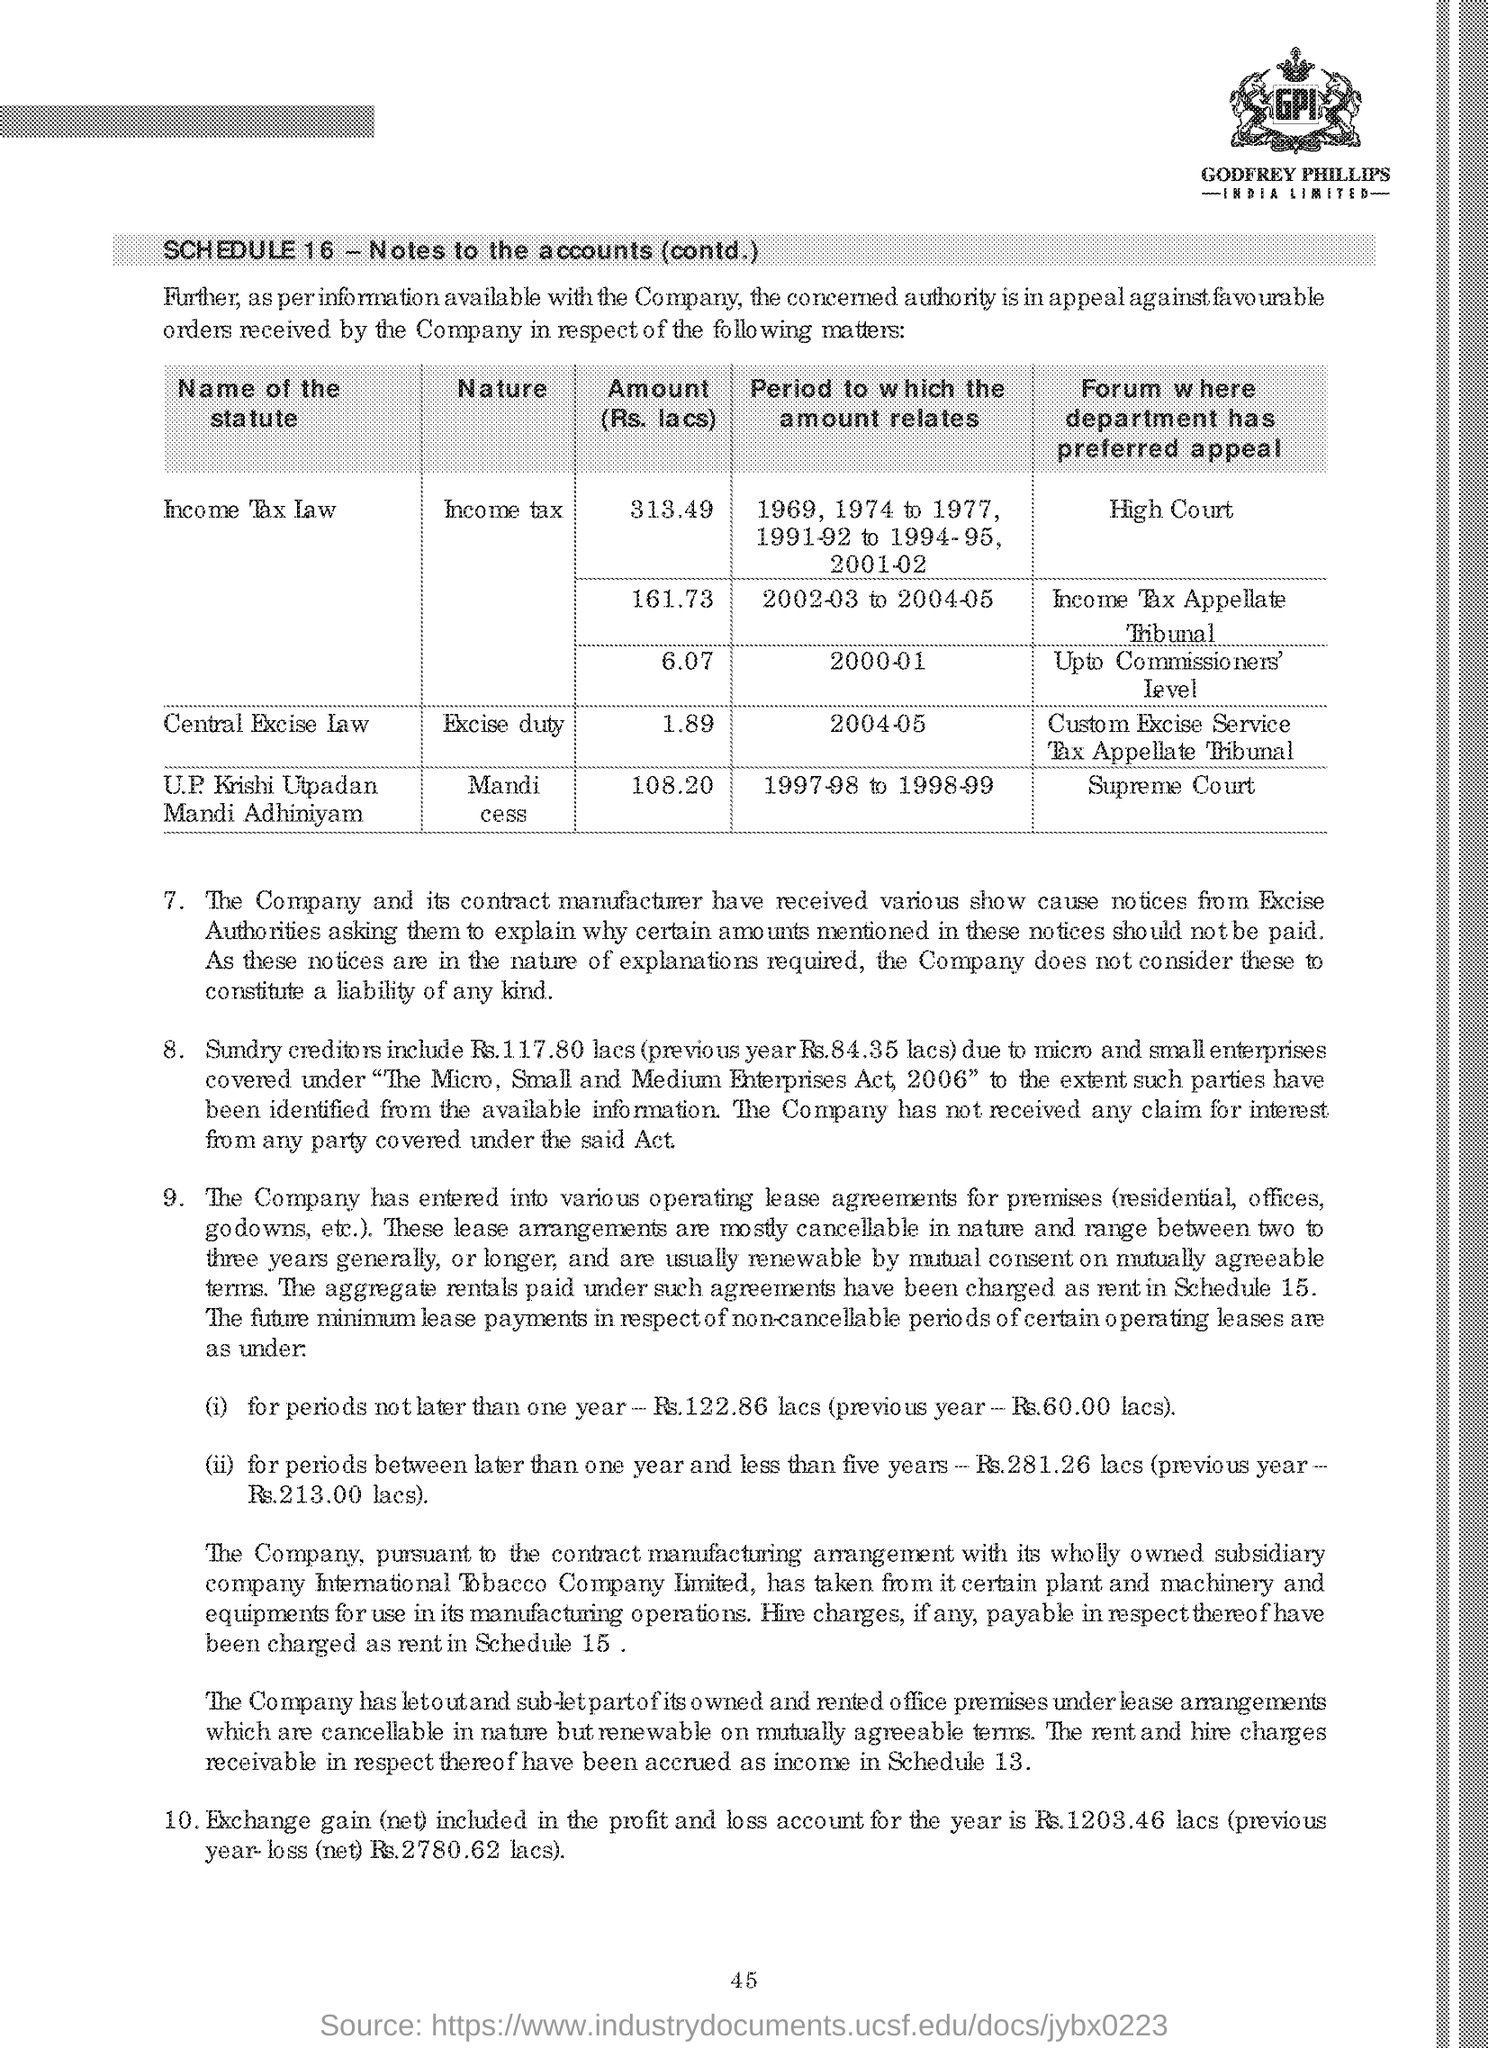Draw attention to some important aspects in this diagram. The "period to which the amount relates" for the "Central Excise law" is 2004-2005. The first statute in the table is Income Tax Law. The amount for the period 2000-01 under the statute "Income Tax law" is 6,07,000 lacs. In the top right corner of the document, the logo is present, which is named as GPI. The statute "U.P. Krishi Utpadan Mandi Adhiniyam" is nature-based, as indicated by the table, which lists various taxes and fees, including mandi cess, that are imposed on agricultural produce traded in mandis. 